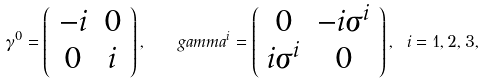Convert formula to latex. <formula><loc_0><loc_0><loc_500><loc_500>\gamma ^ { 0 } = \left ( \begin{array} { c c } - i & 0 \\ 0 & i \end{array} \right ) , \quad g a m m a ^ { i } = \left ( \begin{array} { c c } 0 & - i \sigma ^ { i } \\ i \sigma ^ { i } & 0 \end{array} \right ) , \ i = 1 , 2 , 3 ,</formula> 